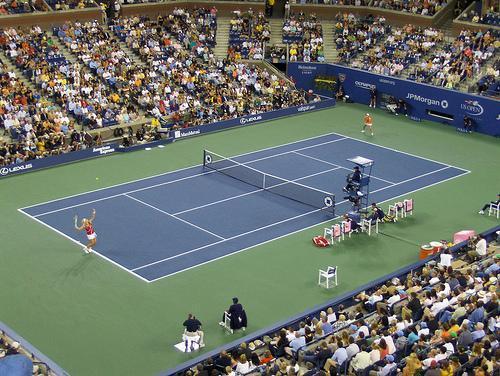How many people are on the court?
Give a very brief answer. 2. How many players are there?
Give a very brief answer. 2. How many nets are there?
Give a very brief answer. 1. 